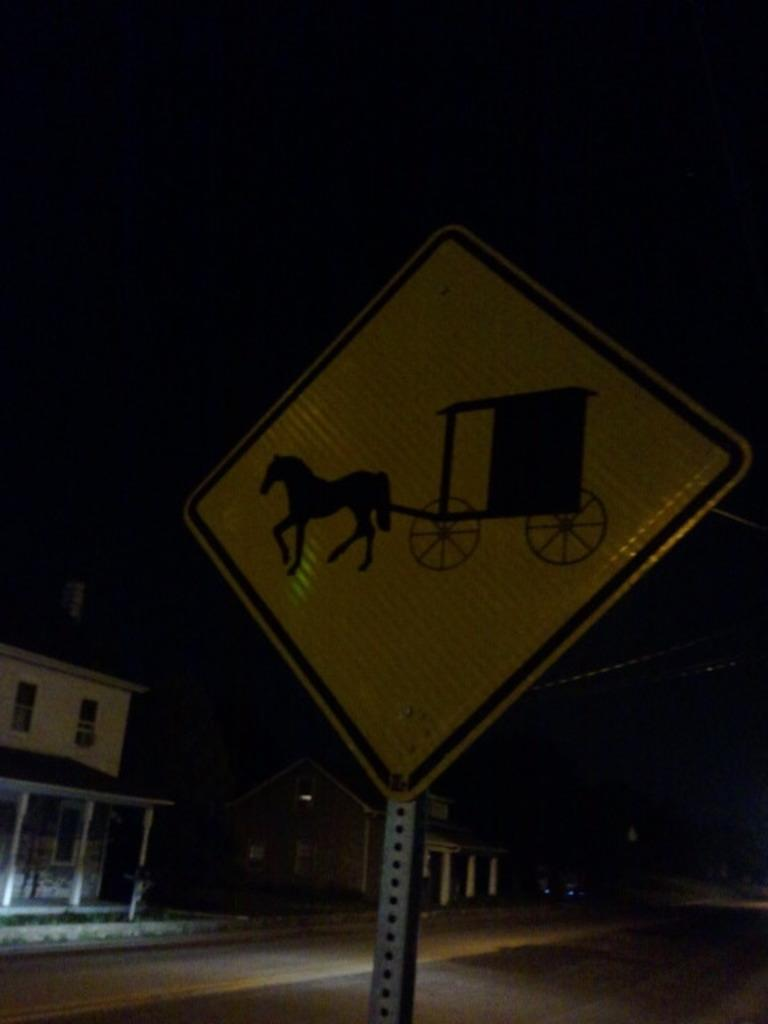What is located on the pole in the image? There is a signboard on a pole in the image. What can be seen in the distance behind the pole? There are houses in the background of the image. How would you describe the lighting in the image? The background of the image is dark. How many legs can be seen on the signboard in the image? Signboards do not have legs, so there are none visible in the image. 